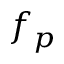<formula> <loc_0><loc_0><loc_500><loc_500>f _ { p }</formula> 